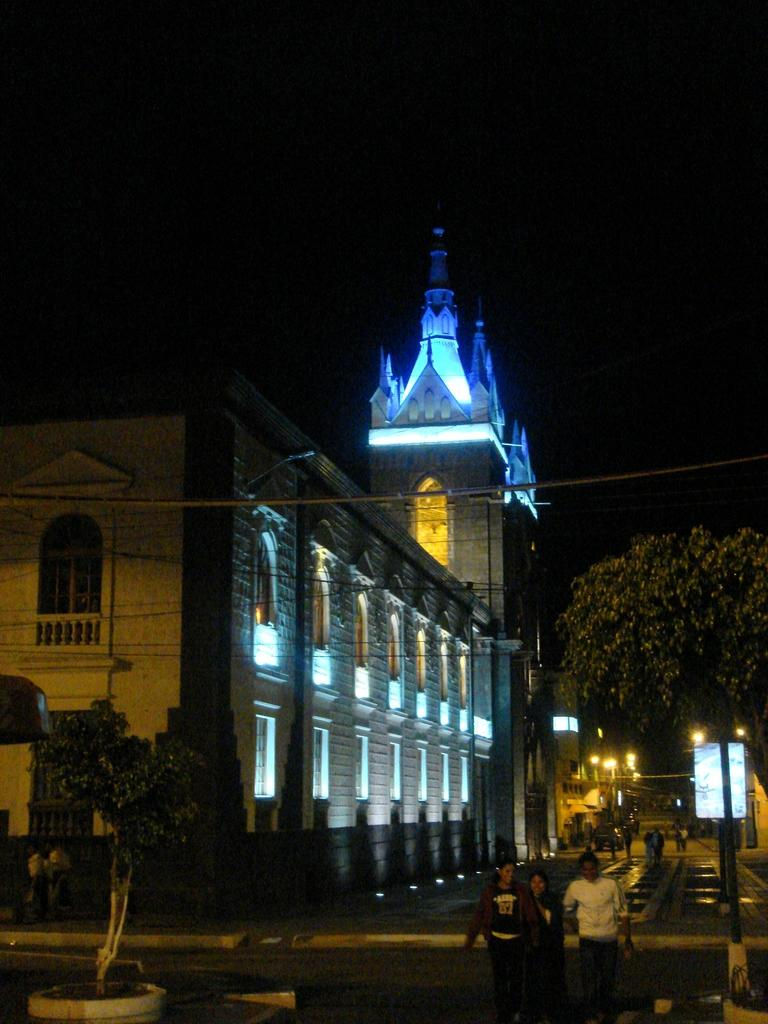What type of structures can be seen in the image? There are buildings in the image. What natural elements are present in the image? There are trees in the image. What type of lighting is present in the image? There are street lights in the image. What living beings can be seen on the ground in the image? There are people on the ground in the image. What is visible in the background of the image? There is a board and the sky visible in the background of the image. Can you tell me how many carts are being pulled by horses in the image? There are no carts or horses present in the image. What type of prose is being recited by the people in the image? There is no indication of any prose being recited in the image; the people are simply standing on the ground. 